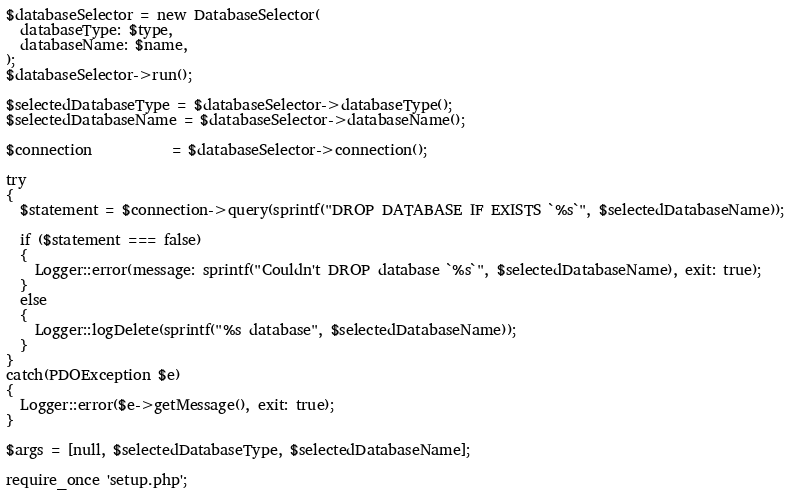Convert code to text. <code><loc_0><loc_0><loc_500><loc_500><_PHP_>$databaseSelector = new DatabaseSelector(
  databaseType: $type,
  databaseName: $name,
);
$databaseSelector->run();

$selectedDatabaseType = $databaseSelector->databaseType();
$selectedDatabaseName = $databaseSelector->databaseName();

$connection           = $databaseSelector->connection();

try
{
  $statement = $connection->query(sprintf("DROP DATABASE IF EXISTS `%s`", $selectedDatabaseName));

  if ($statement === false)
  {
    Logger::error(message: sprintf("Couldn't DROP database `%s`", $selectedDatabaseName), exit: true);
  }
  else
  {
    Logger::logDelete(sprintf("%s database", $selectedDatabaseName));
  }
}
catch(PDOException $e)
{
  Logger::error($e->getMessage(), exit: true);
}

$args = [null, $selectedDatabaseType, $selectedDatabaseName];

require_once 'setup.php';</code> 